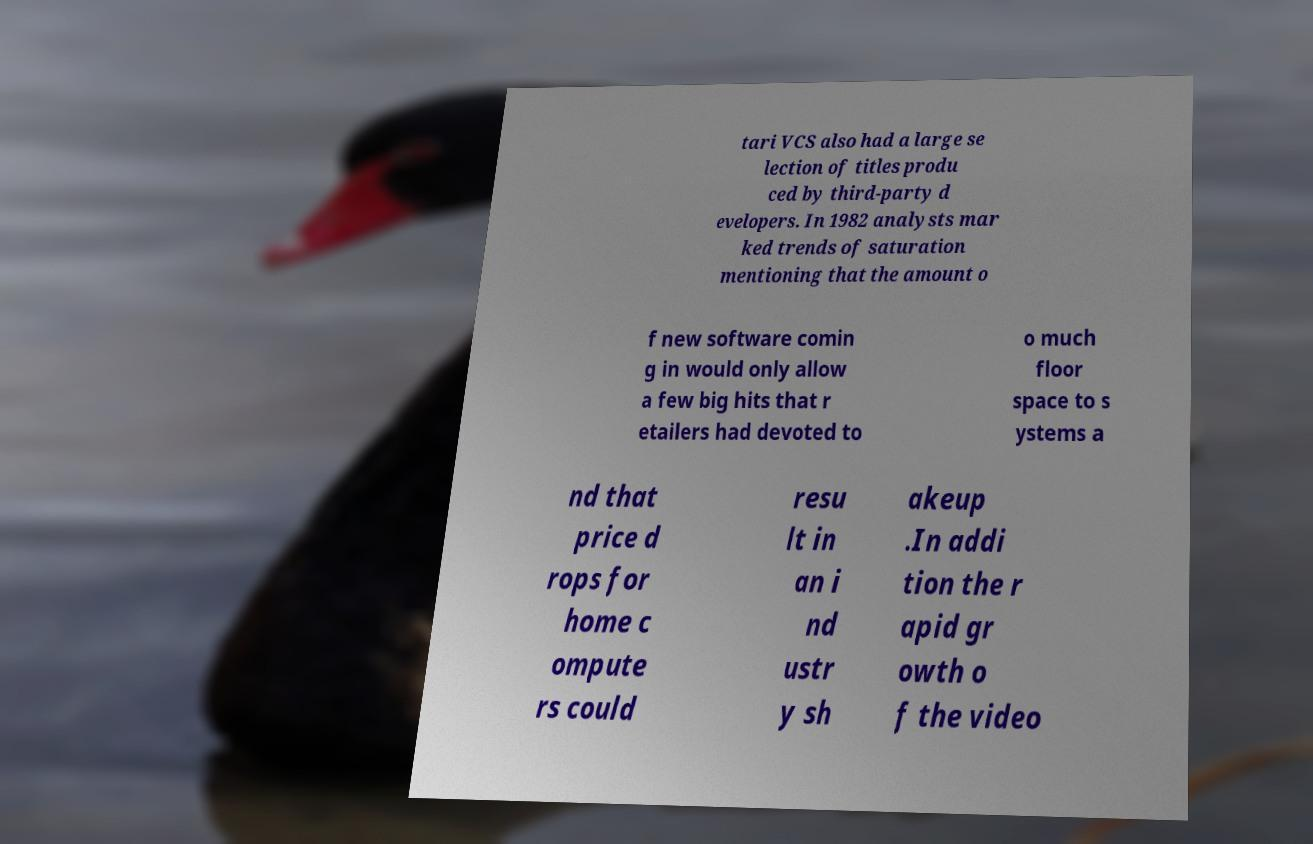Could you assist in decoding the text presented in this image and type it out clearly? tari VCS also had a large se lection of titles produ ced by third-party d evelopers. In 1982 analysts mar ked trends of saturation mentioning that the amount o f new software comin g in would only allow a few big hits that r etailers had devoted to o much floor space to s ystems a nd that price d rops for home c ompute rs could resu lt in an i nd ustr y sh akeup .In addi tion the r apid gr owth o f the video 